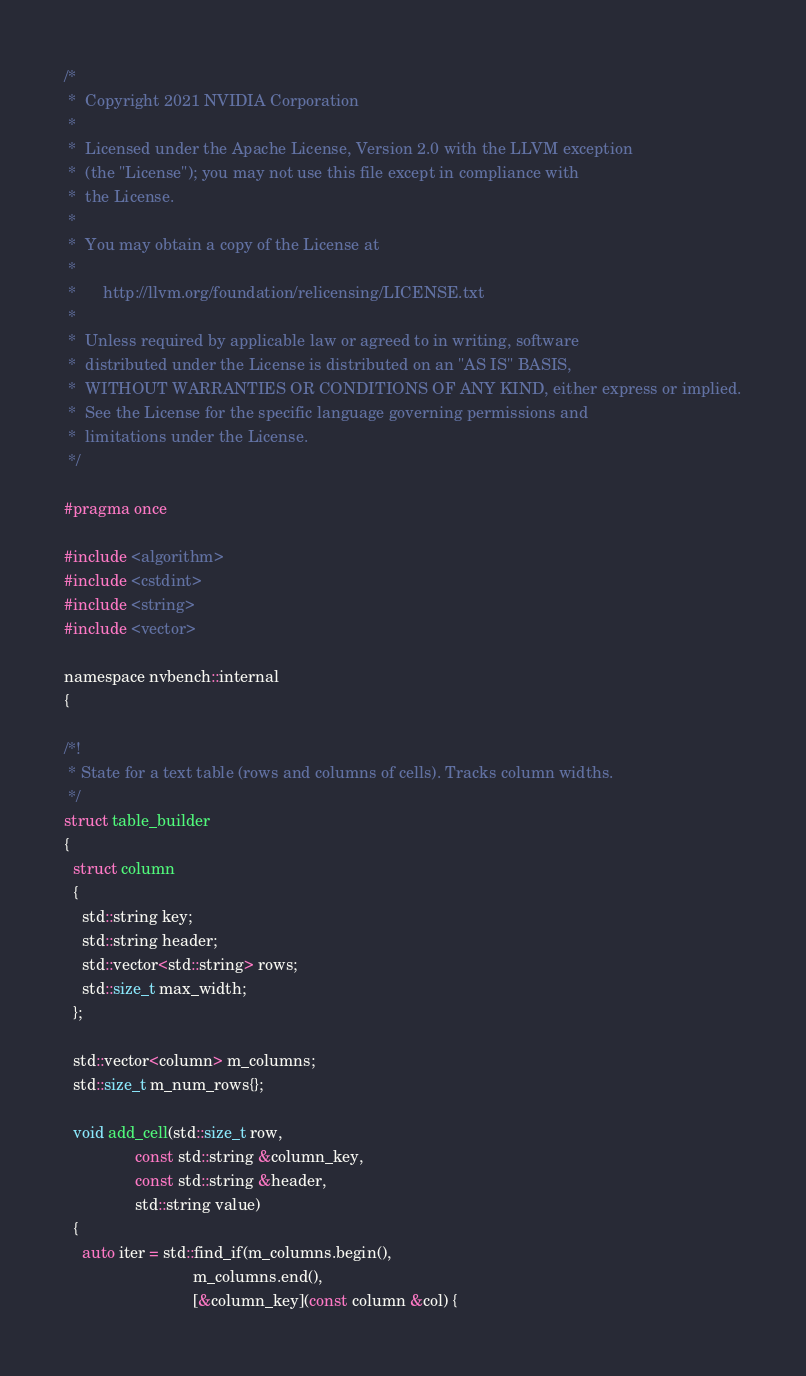Convert code to text. <code><loc_0><loc_0><loc_500><loc_500><_Cuda_>/*
 *  Copyright 2021 NVIDIA Corporation
 *
 *  Licensed under the Apache License, Version 2.0 with the LLVM exception
 *  (the "License"); you may not use this file except in compliance with
 *  the License.
 *
 *  You may obtain a copy of the License at
 *
 *      http://llvm.org/foundation/relicensing/LICENSE.txt
 *
 *  Unless required by applicable law or agreed to in writing, software
 *  distributed under the License is distributed on an "AS IS" BASIS,
 *  WITHOUT WARRANTIES OR CONDITIONS OF ANY KIND, either express or implied.
 *  See the License for the specific language governing permissions and
 *  limitations under the License.
 */

#pragma once

#include <algorithm>
#include <cstdint>
#include <string>
#include <vector>

namespace nvbench::internal
{

/*!
 * State for a text table (rows and columns of cells). Tracks column widths.
 */
struct table_builder
{
  struct column
  {
    std::string key;
    std::string header;
    std::vector<std::string> rows;
    std::size_t max_width;
  };

  std::vector<column> m_columns;
  std::size_t m_num_rows{};

  void add_cell(std::size_t row,
                const std::string &column_key,
                const std::string &header,
                std::string value)
  {
    auto iter = std::find_if(m_columns.begin(),
                             m_columns.end(),
                             [&column_key](const column &col) {</code> 